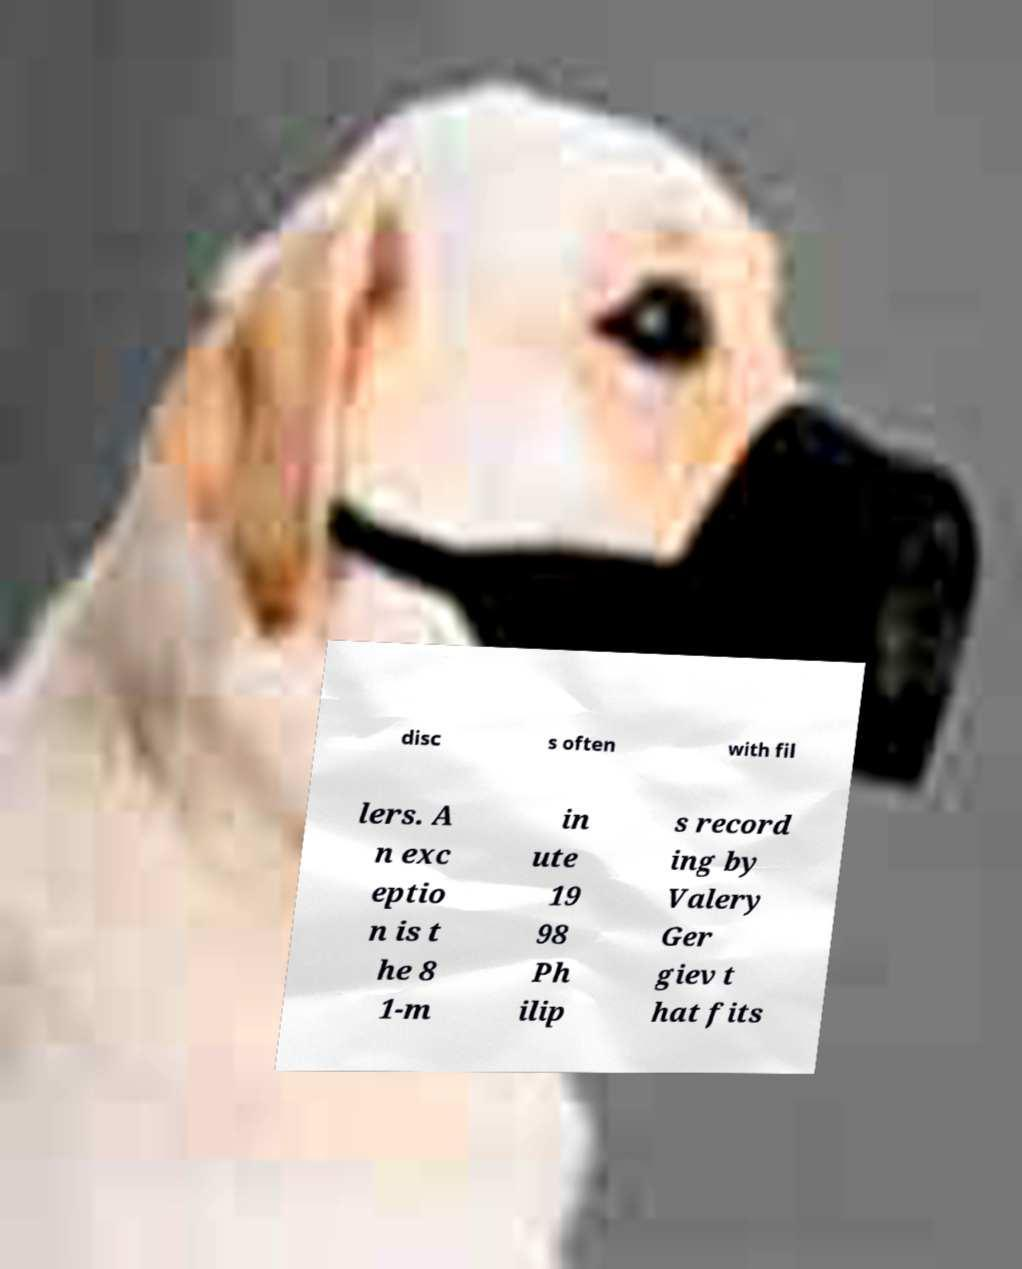Could you extract and type out the text from this image? disc s often with fil lers. A n exc eptio n is t he 8 1-m in ute 19 98 Ph ilip s record ing by Valery Ger giev t hat fits 